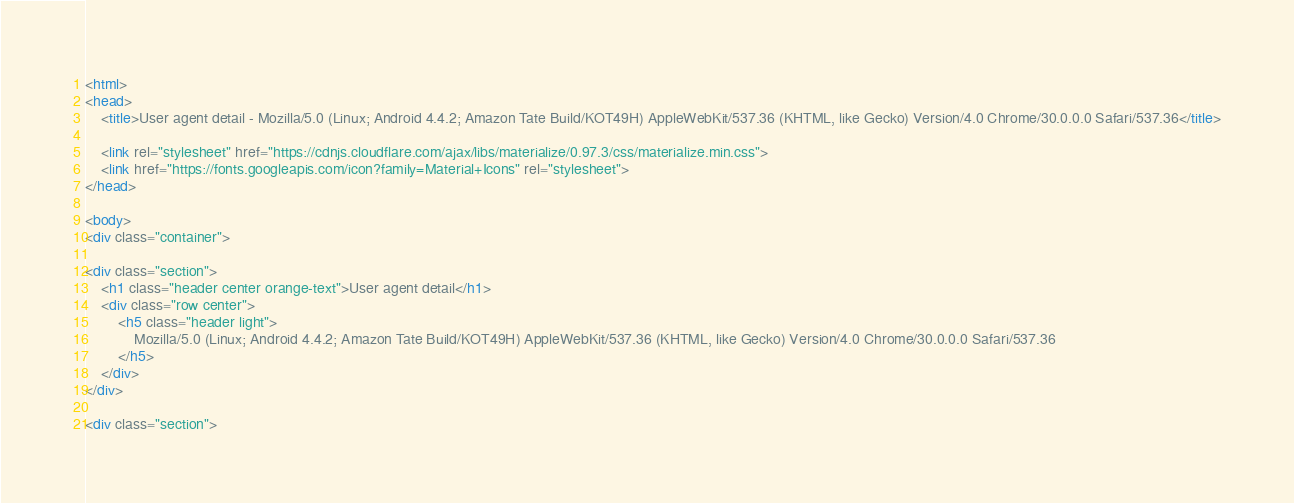Convert code to text. <code><loc_0><loc_0><loc_500><loc_500><_HTML_>
<html>
<head>
    <title>User agent detail - Mozilla/5.0 (Linux; Android 4.4.2; Amazon Tate Build/KOT49H) AppleWebKit/537.36 (KHTML, like Gecko) Version/4.0 Chrome/30.0.0.0 Safari/537.36</title>
        
    <link rel="stylesheet" href="https://cdnjs.cloudflare.com/ajax/libs/materialize/0.97.3/css/materialize.min.css">
    <link href="https://fonts.googleapis.com/icon?family=Material+Icons" rel="stylesheet">
</head>
        
<body>
<div class="container">
    
<div class="section">
	<h1 class="header center orange-text">User agent detail</h1>
	<div class="row center">
        <h5 class="header light">
            Mozilla/5.0 (Linux; Android 4.4.2; Amazon Tate Build/KOT49H) AppleWebKit/537.36 (KHTML, like Gecko) Version/4.0 Chrome/30.0.0.0 Safari/537.36
        </h5>
	</div>
</div>   

<div class="section"></code> 